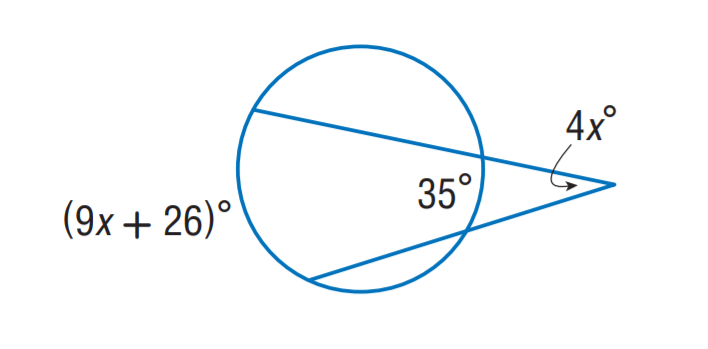What geometric principles can we learn from this image? This image serves as a great example of the properties of tangents to a circle, where a tangent is perpendicular to the radius at the point of contact. It also illustrates complementary angles, which are two angles that add up to 90 degrees. 